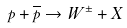Convert formula to latex. <formula><loc_0><loc_0><loc_500><loc_500>p + { \overline { p } } \to W ^ { \pm } + X</formula> 